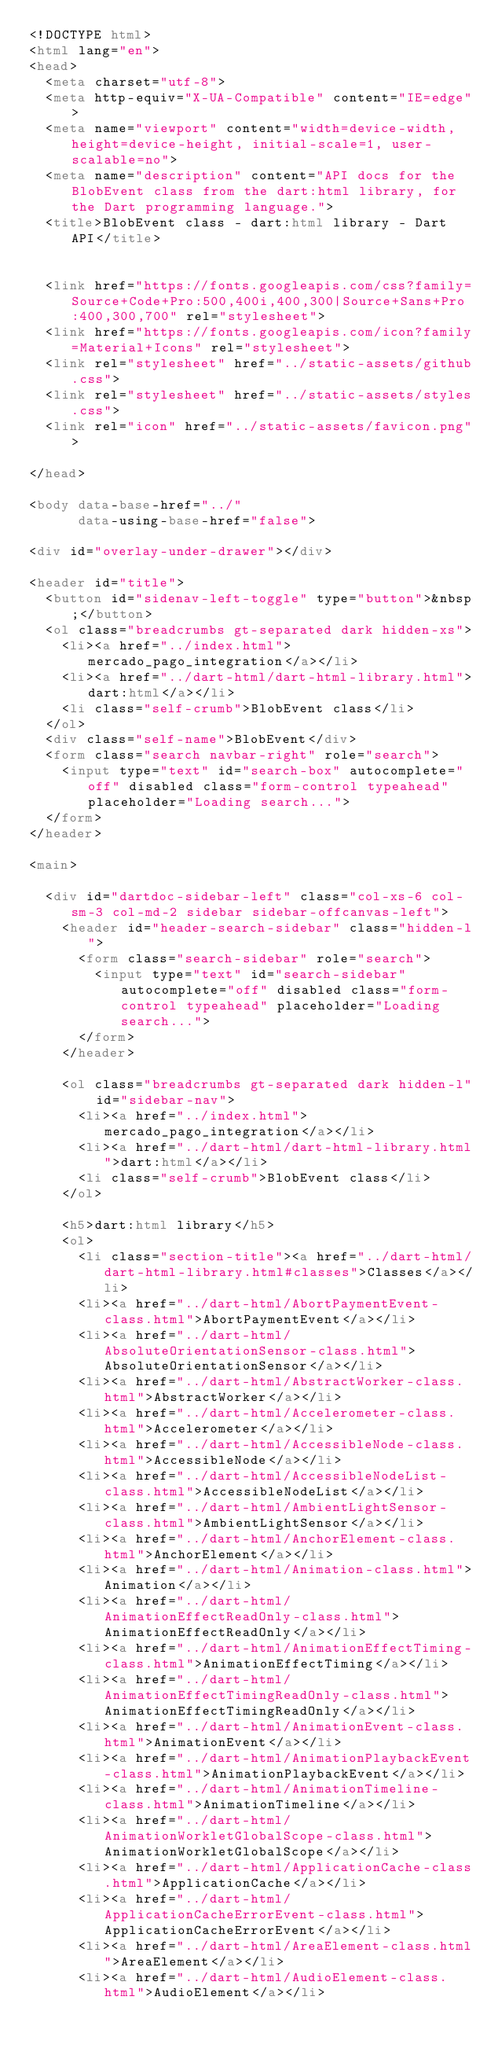Convert code to text. <code><loc_0><loc_0><loc_500><loc_500><_HTML_><!DOCTYPE html>
<html lang="en">
<head>
  <meta charset="utf-8">
  <meta http-equiv="X-UA-Compatible" content="IE=edge">
  <meta name="viewport" content="width=device-width, height=device-height, initial-scale=1, user-scalable=no">
  <meta name="description" content="API docs for the BlobEvent class from the dart:html library, for the Dart programming language.">
  <title>BlobEvent class - dart:html library - Dart API</title>

  
  <link href="https://fonts.googleapis.com/css?family=Source+Code+Pro:500,400i,400,300|Source+Sans+Pro:400,300,700" rel="stylesheet">
  <link href="https://fonts.googleapis.com/icon?family=Material+Icons" rel="stylesheet">
  <link rel="stylesheet" href="../static-assets/github.css">
  <link rel="stylesheet" href="../static-assets/styles.css">
  <link rel="icon" href="../static-assets/favicon.png">

</head>

<body data-base-href="../"
      data-using-base-href="false">

<div id="overlay-under-drawer"></div>

<header id="title">
  <button id="sidenav-left-toggle" type="button">&nbsp;</button>
  <ol class="breadcrumbs gt-separated dark hidden-xs">
    <li><a href="../index.html">mercado_pago_integration</a></li>
    <li><a href="../dart-html/dart-html-library.html">dart:html</a></li>
    <li class="self-crumb">BlobEvent class</li>
  </ol>
  <div class="self-name">BlobEvent</div>
  <form class="search navbar-right" role="search">
    <input type="text" id="search-box" autocomplete="off" disabled class="form-control typeahead" placeholder="Loading search...">
  </form>
</header>

<main>

  <div id="dartdoc-sidebar-left" class="col-xs-6 col-sm-3 col-md-2 sidebar sidebar-offcanvas-left">
    <header id="header-search-sidebar" class="hidden-l">
      <form class="search-sidebar" role="search">
        <input type="text" id="search-sidebar" autocomplete="off" disabled class="form-control typeahead" placeholder="Loading search...">
      </form>
    </header>
    
    <ol class="breadcrumbs gt-separated dark hidden-l" id="sidebar-nav">
      <li><a href="../index.html">mercado_pago_integration</a></li>
      <li><a href="../dart-html/dart-html-library.html">dart:html</a></li>
      <li class="self-crumb">BlobEvent class</li>
    </ol>
    
    <h5>dart:html library</h5>
    <ol>
      <li class="section-title"><a href="../dart-html/dart-html-library.html#classes">Classes</a></li>
      <li><a href="../dart-html/AbortPaymentEvent-class.html">AbortPaymentEvent</a></li>
      <li><a href="../dart-html/AbsoluteOrientationSensor-class.html">AbsoluteOrientationSensor</a></li>
      <li><a href="../dart-html/AbstractWorker-class.html">AbstractWorker</a></li>
      <li><a href="../dart-html/Accelerometer-class.html">Accelerometer</a></li>
      <li><a href="../dart-html/AccessibleNode-class.html">AccessibleNode</a></li>
      <li><a href="../dart-html/AccessibleNodeList-class.html">AccessibleNodeList</a></li>
      <li><a href="../dart-html/AmbientLightSensor-class.html">AmbientLightSensor</a></li>
      <li><a href="../dart-html/AnchorElement-class.html">AnchorElement</a></li>
      <li><a href="../dart-html/Animation-class.html">Animation</a></li>
      <li><a href="../dart-html/AnimationEffectReadOnly-class.html">AnimationEffectReadOnly</a></li>
      <li><a href="../dart-html/AnimationEffectTiming-class.html">AnimationEffectTiming</a></li>
      <li><a href="../dart-html/AnimationEffectTimingReadOnly-class.html">AnimationEffectTimingReadOnly</a></li>
      <li><a href="../dart-html/AnimationEvent-class.html">AnimationEvent</a></li>
      <li><a href="../dart-html/AnimationPlaybackEvent-class.html">AnimationPlaybackEvent</a></li>
      <li><a href="../dart-html/AnimationTimeline-class.html">AnimationTimeline</a></li>
      <li><a href="../dart-html/AnimationWorkletGlobalScope-class.html">AnimationWorkletGlobalScope</a></li>
      <li><a href="../dart-html/ApplicationCache-class.html">ApplicationCache</a></li>
      <li><a href="../dart-html/ApplicationCacheErrorEvent-class.html">ApplicationCacheErrorEvent</a></li>
      <li><a href="../dart-html/AreaElement-class.html">AreaElement</a></li>
      <li><a href="../dart-html/AudioElement-class.html">AudioElement</a></li></code> 